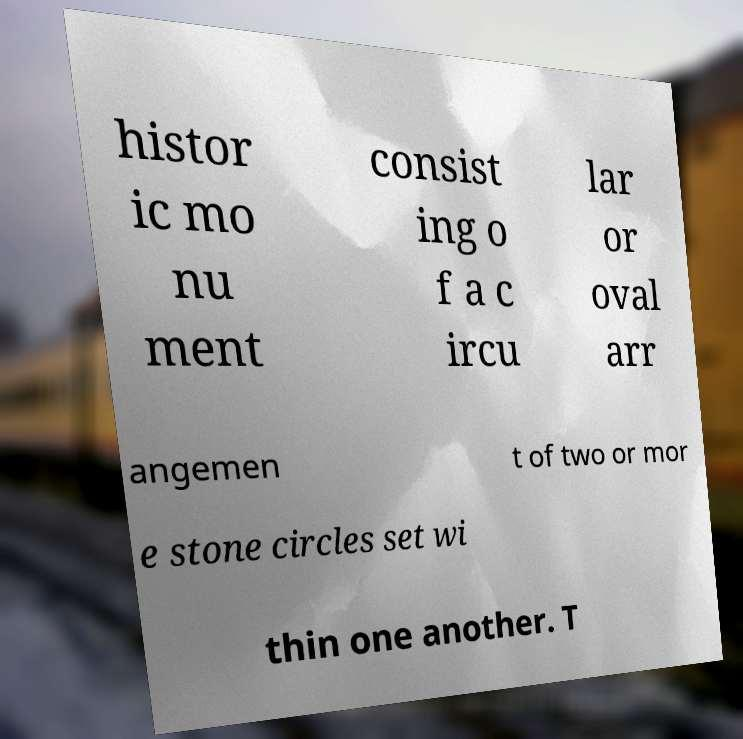For documentation purposes, I need the text within this image transcribed. Could you provide that? histor ic mo nu ment consist ing o f a c ircu lar or oval arr angemen t of two or mor e stone circles set wi thin one another. T 